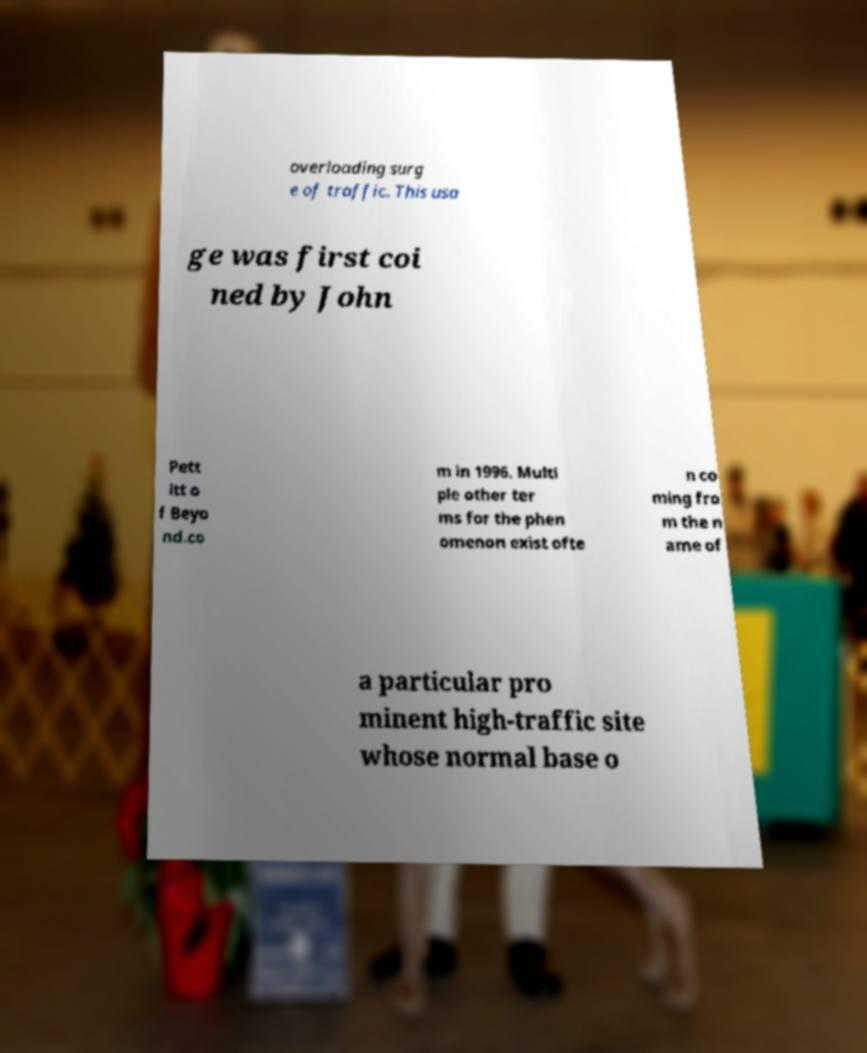Please read and relay the text visible in this image. What does it say? overloading surg e of traffic. This usa ge was first coi ned by John Pett itt o f Beyo nd.co m in 1996. Multi ple other ter ms for the phen omenon exist ofte n co ming fro m the n ame of a particular pro minent high-traffic site whose normal base o 